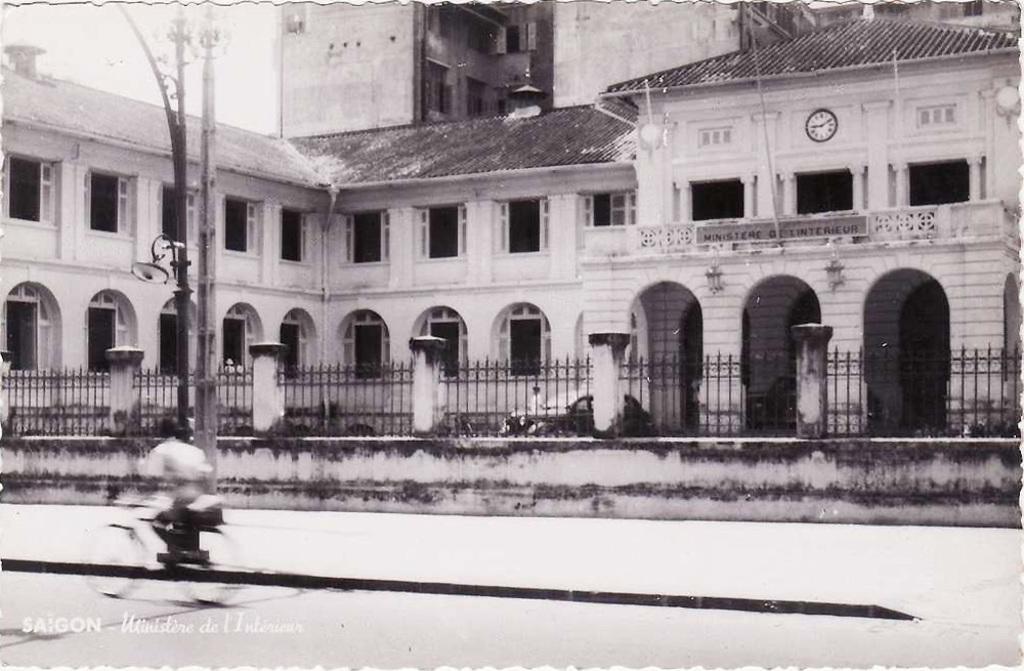Please provide a concise description of this image. In this image we can see a person riding a bicycle on the road. In the background ,we can see a iron fence a building ,group of poles and the sky. 